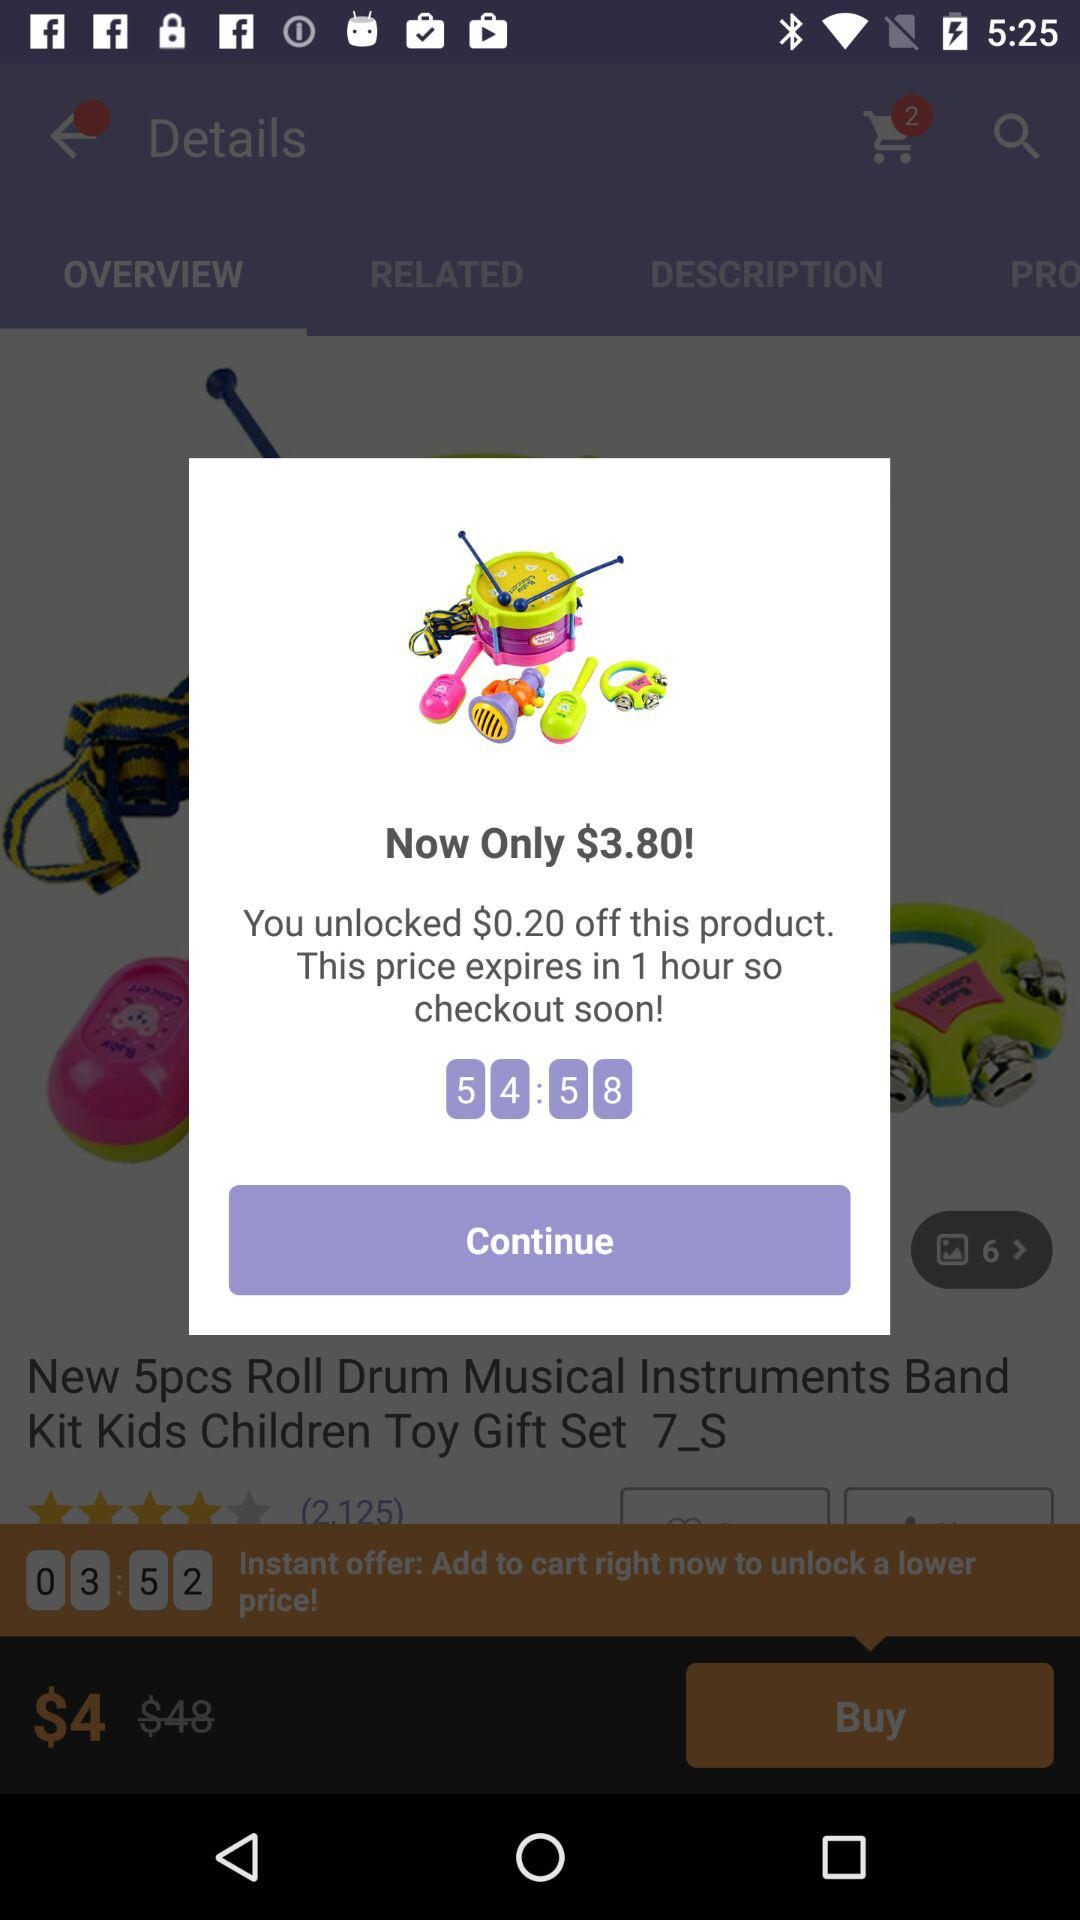What is the unlock amount? The unlock amount is $3.80. 